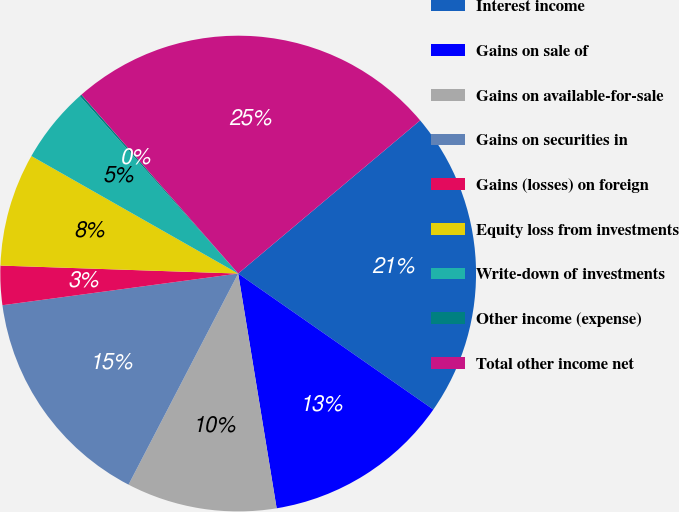Convert chart to OTSL. <chart><loc_0><loc_0><loc_500><loc_500><pie_chart><fcel>Interest income<fcel>Gains on sale of<fcel>Gains on available-for-sale<fcel>Gains on securities in<fcel>Gains (losses) on foreign<fcel>Equity loss from investments<fcel>Write-down of investments<fcel>Other income (expense)<fcel>Total other income net<nl><fcel>20.82%<fcel>12.73%<fcel>10.21%<fcel>15.25%<fcel>2.66%<fcel>7.69%<fcel>5.18%<fcel>0.14%<fcel>25.32%<nl></chart> 